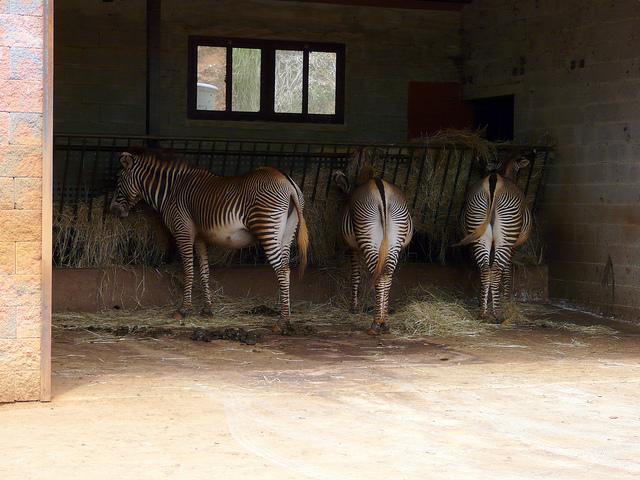How many animals are sitting?
Give a very brief answer. 0. How many zebras are in the picture?
Give a very brief answer. 3. 